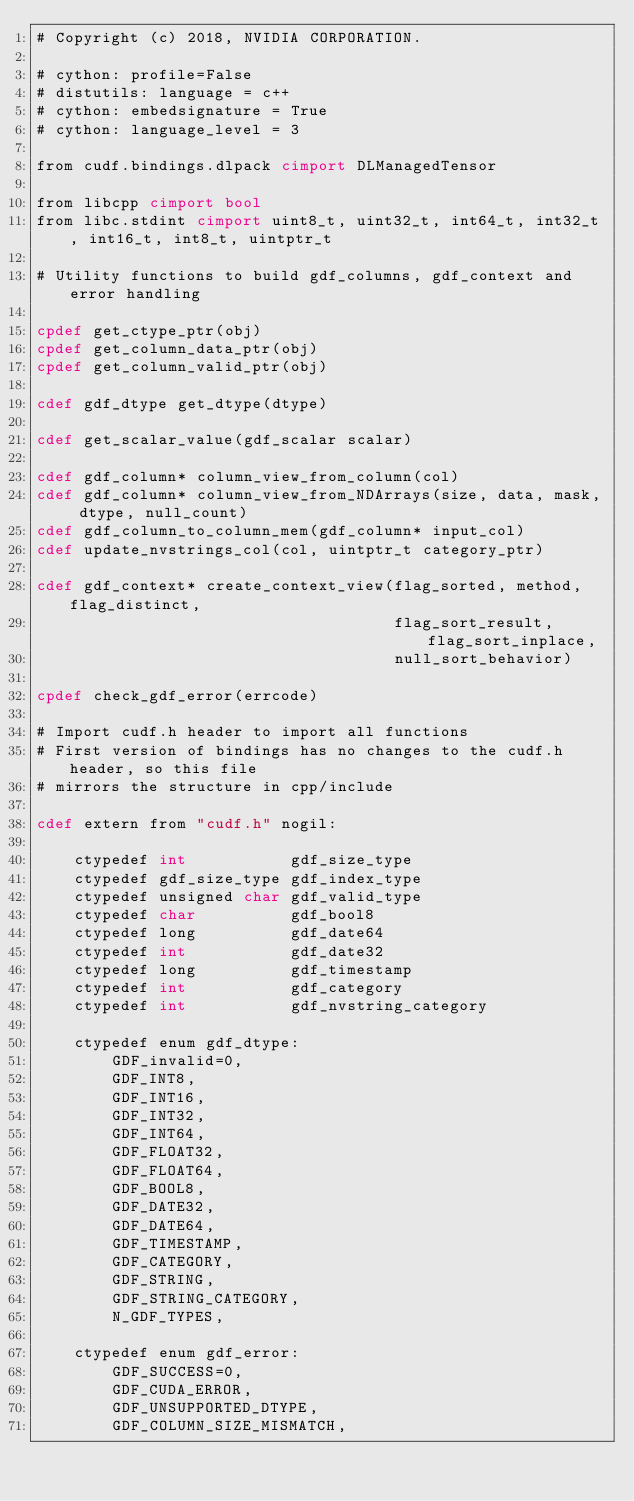Convert code to text. <code><loc_0><loc_0><loc_500><loc_500><_Cython_># Copyright (c) 2018, NVIDIA CORPORATION.

# cython: profile=False
# distutils: language = c++
# cython: embedsignature = True
# cython: language_level = 3

from cudf.bindings.dlpack cimport DLManagedTensor

from libcpp cimport bool
from libc.stdint cimport uint8_t, uint32_t, int64_t, int32_t, int16_t, int8_t, uintptr_t

# Utility functions to build gdf_columns, gdf_context and error handling

cpdef get_ctype_ptr(obj)
cpdef get_column_data_ptr(obj)
cpdef get_column_valid_ptr(obj)

cdef gdf_dtype get_dtype(dtype)

cdef get_scalar_value(gdf_scalar scalar)

cdef gdf_column* column_view_from_column(col)
cdef gdf_column* column_view_from_NDArrays(size, data, mask, dtype, null_count)
cdef gdf_column_to_column_mem(gdf_column* input_col)
cdef update_nvstrings_col(col, uintptr_t category_ptr)

cdef gdf_context* create_context_view(flag_sorted, method, flag_distinct,
                                      flag_sort_result, flag_sort_inplace,
                                      null_sort_behavior)

cpdef check_gdf_error(errcode)

# Import cudf.h header to import all functions
# First version of bindings has no changes to the cudf.h header, so this file
# mirrors the structure in cpp/include

cdef extern from "cudf.h" nogil:

    ctypedef int           gdf_size_type
    ctypedef gdf_size_type gdf_index_type
    ctypedef unsigned char gdf_valid_type
    ctypedef char          gdf_bool8
    ctypedef long          gdf_date64
    ctypedef int           gdf_date32
    ctypedef long          gdf_timestamp
    ctypedef int           gdf_category
    ctypedef int           gdf_nvstring_category

    ctypedef enum gdf_dtype:
        GDF_invalid=0,
        GDF_INT8,
        GDF_INT16,
        GDF_INT32,
        GDF_INT64,
        GDF_FLOAT32,
        GDF_FLOAT64,
        GDF_BOOL8,
        GDF_DATE32,
        GDF_DATE64,
        GDF_TIMESTAMP,
        GDF_CATEGORY,
        GDF_STRING,
        GDF_STRING_CATEGORY,
        N_GDF_TYPES,

    ctypedef enum gdf_error:
        GDF_SUCCESS=0,
        GDF_CUDA_ERROR,
        GDF_UNSUPPORTED_DTYPE,
        GDF_COLUMN_SIZE_MISMATCH,</code> 